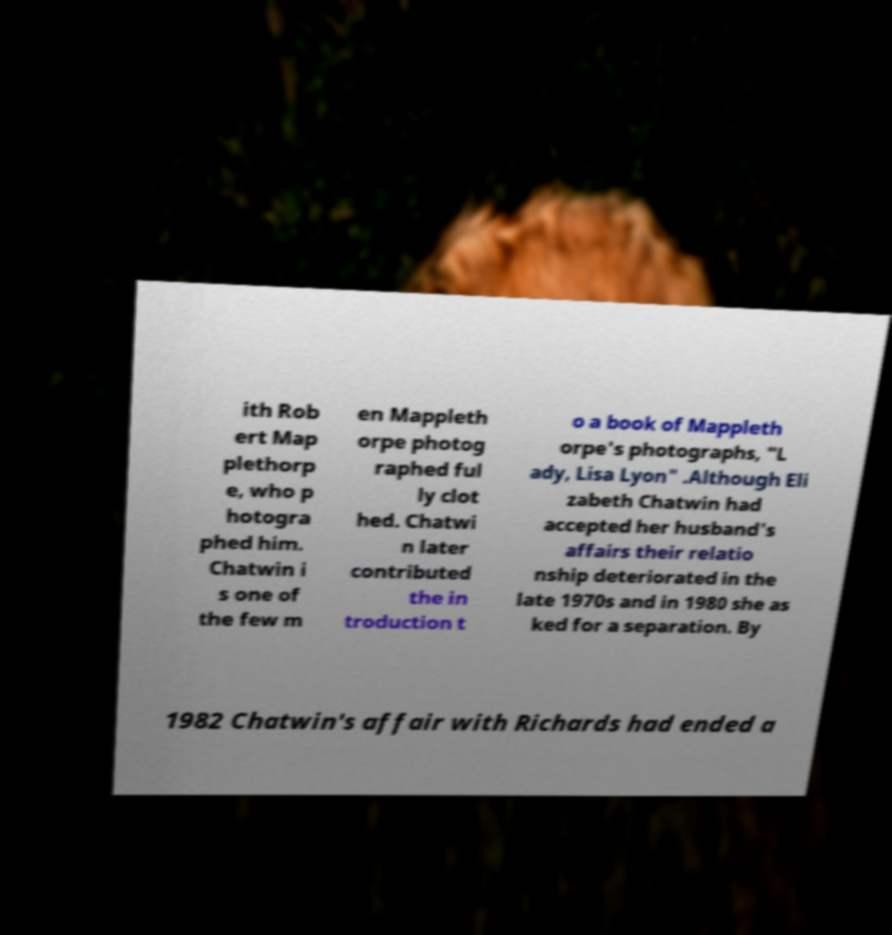What messages or text are displayed in this image? I need them in a readable, typed format. ith Rob ert Map plethorp e, who p hotogra phed him. Chatwin i s one of the few m en Mappleth orpe photog raphed ful ly clot hed. Chatwi n later contributed the in troduction t o a book of Mappleth orpe's photographs, "L ady, Lisa Lyon" .Although Eli zabeth Chatwin had accepted her husband's affairs their relatio nship deteriorated in the late 1970s and in 1980 she as ked for a separation. By 1982 Chatwin's affair with Richards had ended a 